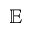<formula> <loc_0><loc_0><loc_500><loc_500>\mathbb { E }</formula> 